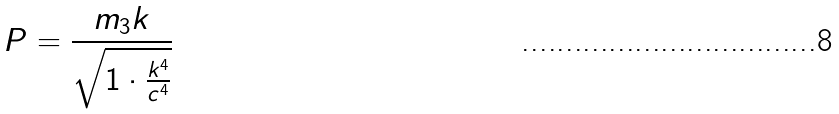<formula> <loc_0><loc_0><loc_500><loc_500>P = \frac { m _ { 3 } k } { \sqrt { 1 \cdot \frac { k ^ { 4 } } { c ^ { 4 } } } }</formula> 